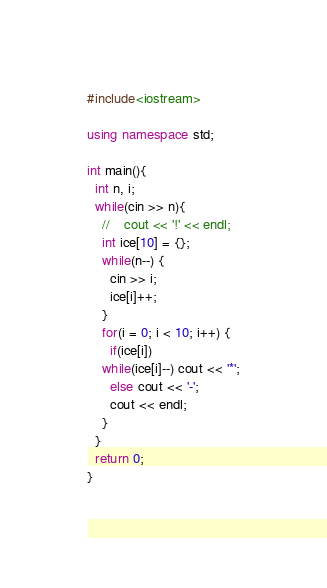<code> <loc_0><loc_0><loc_500><loc_500><_C++_>#include<iostream>

using namespace std;

int main(){
  int n, i;
  while(cin >> n){
    //    cout << '!' << endl;
    int ice[10] = {};
    while(n--) {
      cin >> i;
      ice[i]++;
    }
    for(i = 0; i < 10; i++) {
      if(ice[i])
	while(ice[i]--) cout << '*';
      else cout << '-';
      cout << endl;
    }
  }
  return 0;
}
    </code> 